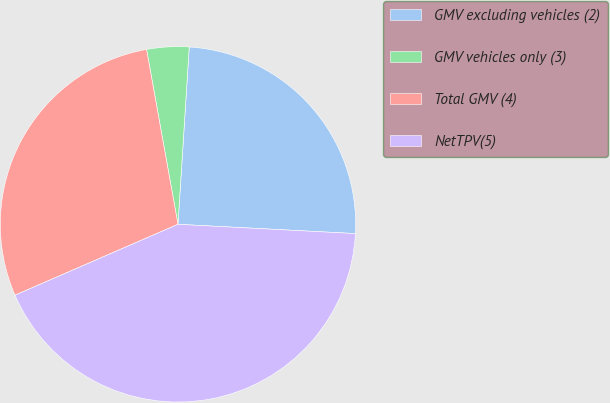<chart> <loc_0><loc_0><loc_500><loc_500><pie_chart><fcel>GMV excluding vehicles (2)<fcel>GMV vehicles only (3)<fcel>Total GMV (4)<fcel>NetTPV(5)<nl><fcel>24.82%<fcel>3.84%<fcel>28.7%<fcel>42.64%<nl></chart> 